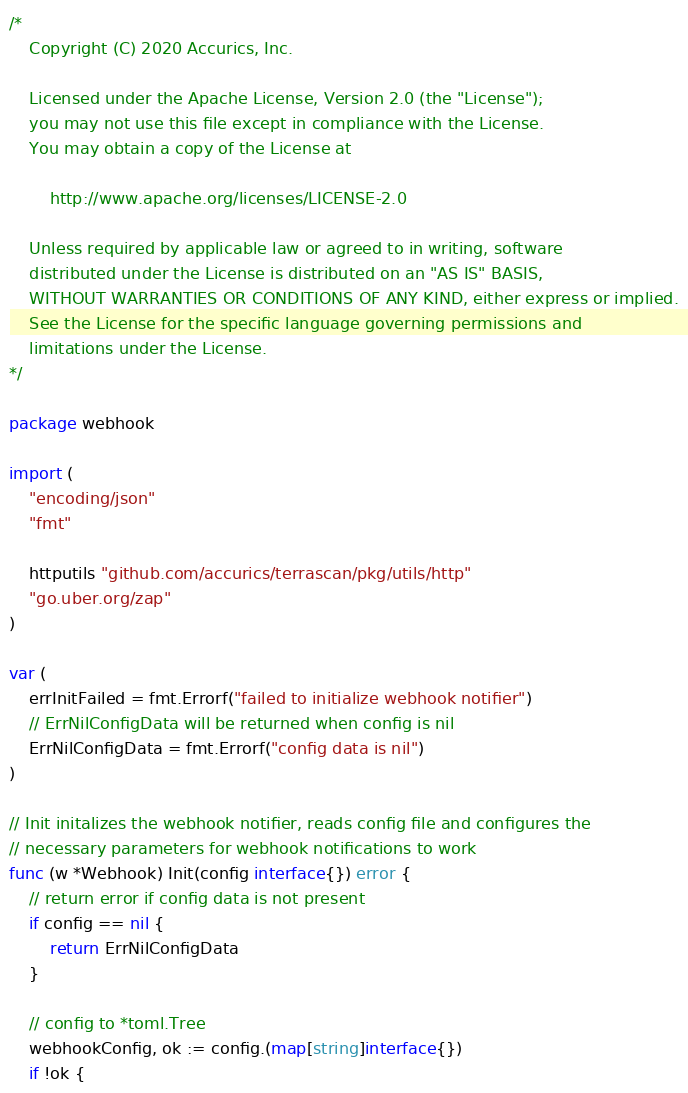Convert code to text. <code><loc_0><loc_0><loc_500><loc_500><_Go_>/*
    Copyright (C) 2020 Accurics, Inc.

	Licensed under the Apache License, Version 2.0 (the "License");
    you may not use this file except in compliance with the License.
    You may obtain a copy of the License at

		http://www.apache.org/licenses/LICENSE-2.0

	Unless required by applicable law or agreed to in writing, software
    distributed under the License is distributed on an "AS IS" BASIS,
    WITHOUT WARRANTIES OR CONDITIONS OF ANY KIND, either express or implied.
    See the License for the specific language governing permissions and
    limitations under the License.
*/

package webhook

import (
	"encoding/json"
	"fmt"

	httputils "github.com/accurics/terrascan/pkg/utils/http"
	"go.uber.org/zap"
)

var (
	errInitFailed = fmt.Errorf("failed to initialize webhook notifier")
	// ErrNilConfigData will be returned when config is nil
	ErrNilConfigData = fmt.Errorf("config data is nil")
)

// Init initalizes the webhook notifier, reads config file and configures the
// necessary parameters for webhook notifications to work
func (w *Webhook) Init(config interface{}) error {
	// return error if config data is not present
	if config == nil {
		return ErrNilConfigData
	}

	// config to *toml.Tree
	webhookConfig, ok := config.(map[string]interface{})
	if !ok {</code> 